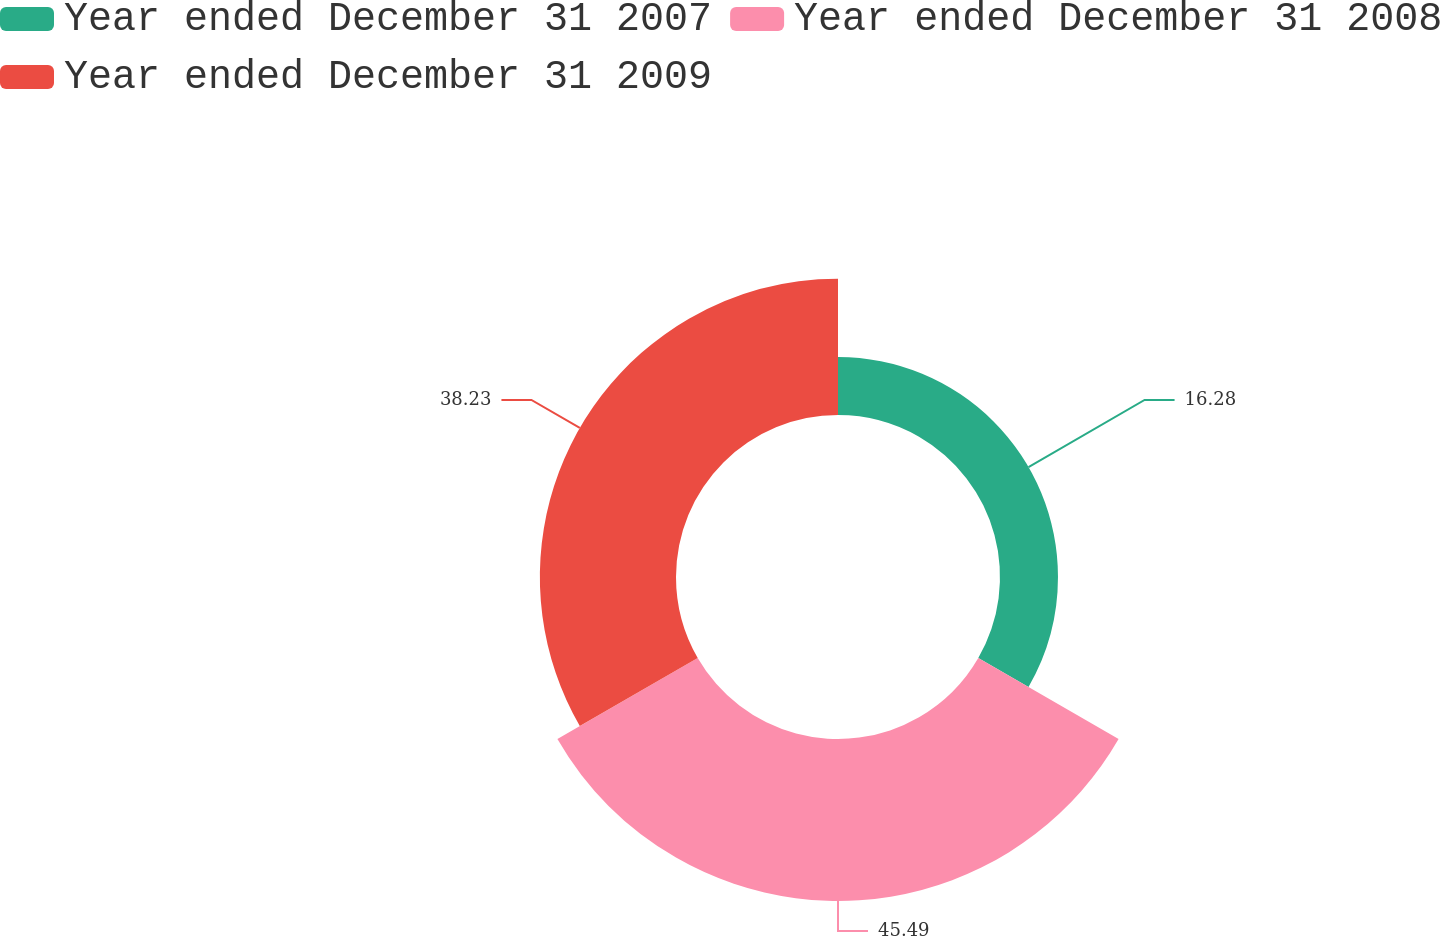Convert chart. <chart><loc_0><loc_0><loc_500><loc_500><pie_chart><fcel>Year ended December 31 2007<fcel>Year ended December 31 2008<fcel>Year ended December 31 2009<nl><fcel>16.28%<fcel>45.49%<fcel>38.23%<nl></chart> 